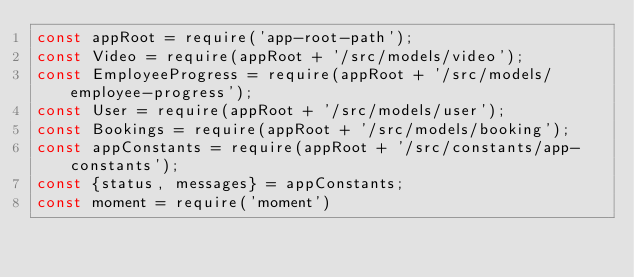<code> <loc_0><loc_0><loc_500><loc_500><_JavaScript_>const appRoot = require('app-root-path');
const Video = require(appRoot + '/src/models/video');
const EmployeeProgress = require(appRoot + '/src/models/employee-progress');
const User = require(appRoot + '/src/models/user');
const Bookings = require(appRoot + '/src/models/booking');
const appConstants = require(appRoot + '/src/constants/app-constants');
const {status, messages} = appConstants;
const moment = require('moment')</code> 